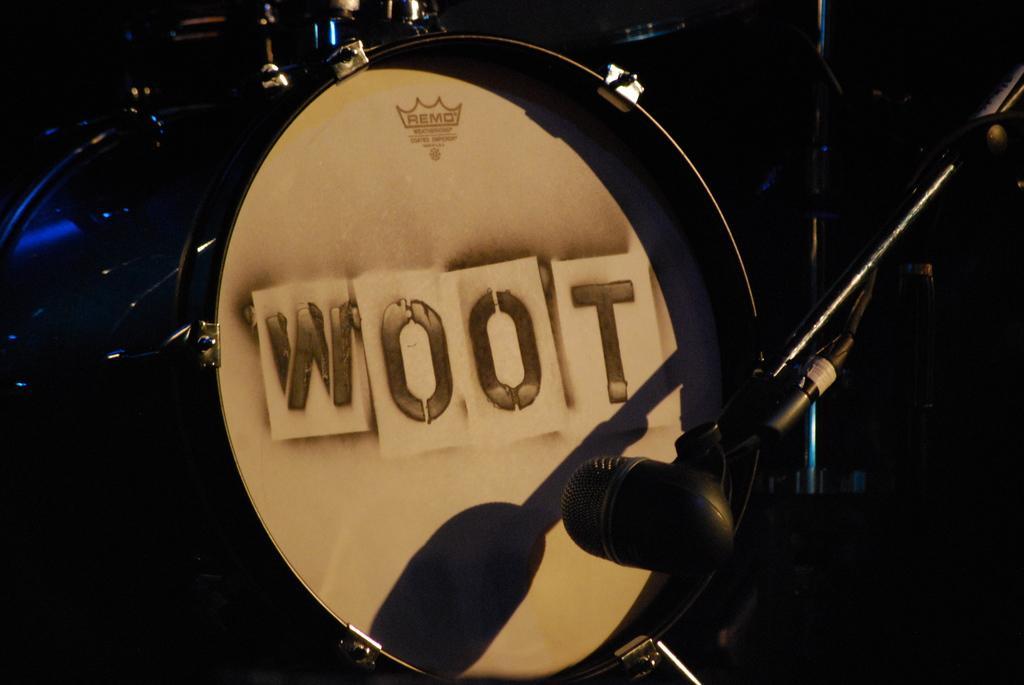How would you summarize this image in a sentence or two? In this picture we can see a drum in front of microphone and we can see dark background. 